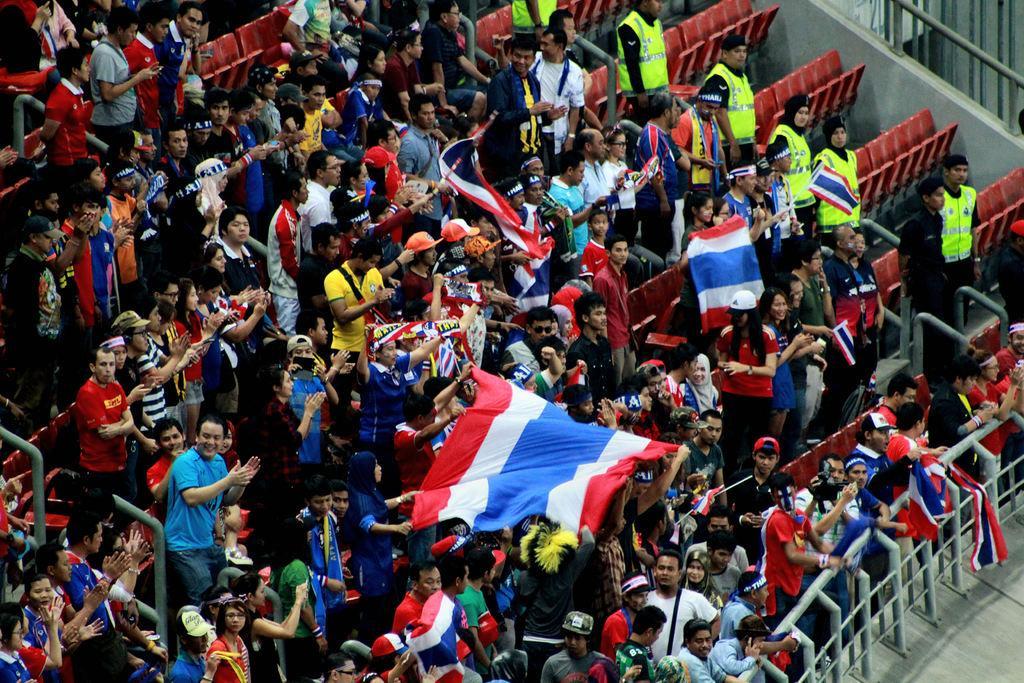Please provide a concise description of this image. In this picture we can see the ground and a group of people, here we can see flags, seats and some objects. 